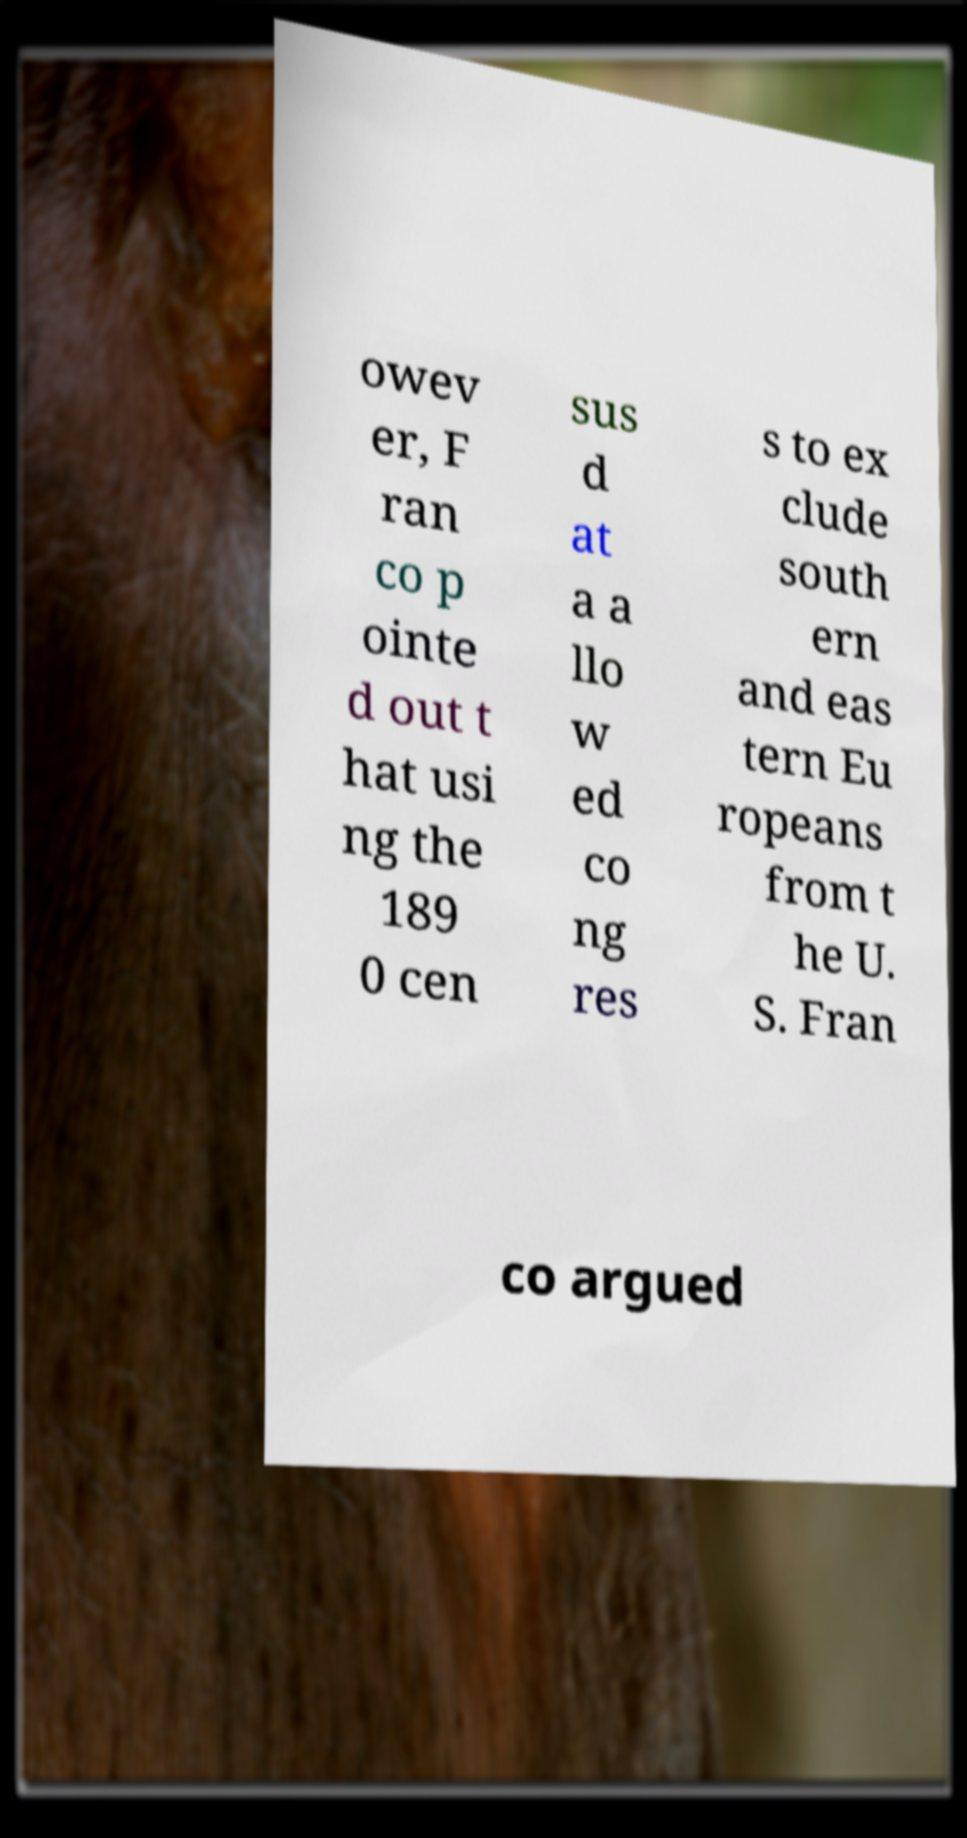What messages or text are displayed in this image? I need them in a readable, typed format. owev er, F ran co p ointe d out t hat usi ng the 189 0 cen sus d at a a llo w ed co ng res s to ex clude south ern and eas tern Eu ropeans from t he U. S. Fran co argued 